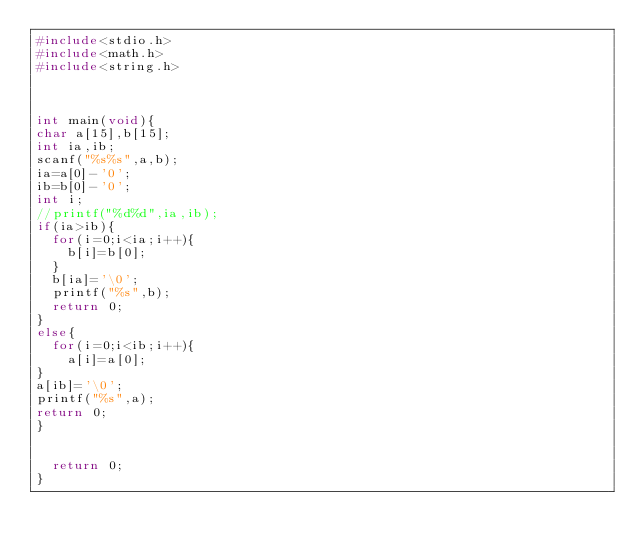<code> <loc_0><loc_0><loc_500><loc_500><_C_>#include<stdio.h>
#include<math.h>
#include<string.h>



int main(void){
char a[15],b[15];
int ia,ib;
scanf("%s%s",a,b);
ia=a[0]-'0';
ib=b[0]-'0';
int i;
//printf("%d%d",ia,ib);
if(ia>ib){
  for(i=0;i<ia;i++){
    b[i]=b[0];
  }
  b[ia]='\0';
  printf("%s",b);
  return 0;
}
else{
  for(i=0;i<ib;i++){
    a[i]=a[0];
}
a[ib]='\0';
printf("%s",a);
return 0;
}


  return 0;
}
</code> 